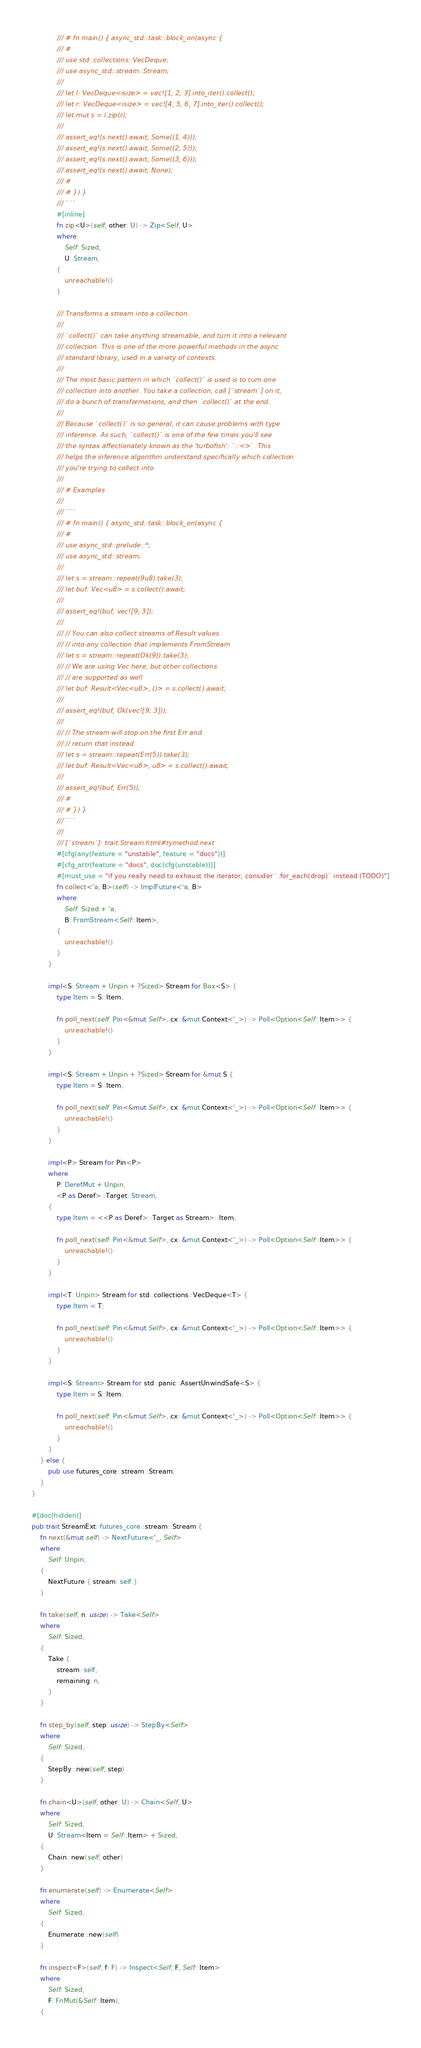<code> <loc_0><loc_0><loc_500><loc_500><_Rust_>            /// # fn main() { async_std::task::block_on(async {
            /// #
            /// use std::collections::VecDeque;
            /// use async_std::stream::Stream;
            ///
            /// let l: VecDeque<isize> = vec![1, 2, 3].into_iter().collect();
            /// let r: VecDeque<isize> = vec![4, 5, 6, 7].into_iter().collect();
            /// let mut s = l.zip(r);
            ///
            /// assert_eq!(s.next().await, Some((1, 4)));
            /// assert_eq!(s.next().await, Some((2, 5)));
            /// assert_eq!(s.next().await, Some((3, 6)));
            /// assert_eq!(s.next().await, None);
            /// #
            /// # }) }
            /// ```
            #[inline]
            fn zip<U>(self, other: U) -> Zip<Self, U>
            where
                Self: Sized,
                U: Stream,
            {
                unreachable!()
            }

            /// Transforms a stream into a collection.
            ///
            /// `collect()` can take anything streamable, and turn it into a relevant
            /// collection. This is one of the more powerful methods in the async
            /// standard library, used in a variety of contexts.
            ///
            /// The most basic pattern in which `collect()` is used is to turn one
            /// collection into another. You take a collection, call [`stream`] on it,
            /// do a bunch of transformations, and then `collect()` at the end.
            ///
            /// Because `collect()` is so general, it can cause problems with type
            /// inference. As such, `collect()` is one of the few times you'll see
            /// the syntax affectionately known as the 'turbofish': `::<>`. This
            /// helps the inference algorithm understand specifically which collection
            /// you're trying to collect into.
            ///
            /// # Examples
            ///
            /// ```
            /// # fn main() { async_std::task::block_on(async {
            /// #
            /// use async_std::prelude::*;
            /// use async_std::stream;
            ///
            /// let s = stream::repeat(9u8).take(3);
            /// let buf: Vec<u8> = s.collect().await;
            ///
            /// assert_eq!(buf, vec![9; 3]);
            ///
            /// // You can also collect streams of Result values
            /// // into any collection that implements FromStream
            /// let s = stream::repeat(Ok(9)).take(3);
            /// // We are using Vec here, but other collections
            /// // are supported as well
            /// let buf: Result<Vec<u8>, ()> = s.collect().await;
            ///
            /// assert_eq!(buf, Ok(vec![9; 3]));
            ///
            /// // The stream will stop on the first Err and
            /// // return that instead
            /// let s = stream::repeat(Err(5)).take(3);
            /// let buf: Result<Vec<u8>, u8> = s.collect().await;
            ///
            /// assert_eq!(buf, Err(5));
            /// #
            /// # }) }
            /// ```
            ///
            /// [`stream`]: trait.Stream.html#tymethod.next
            #[cfg(any(feature = "unstable", feature = "docs"))]
            #[cfg_attr(feature = "docs", doc(cfg(unstable)))]
            #[must_use = "if you really need to exhaust the iterator, consider `.for_each(drop)` instead (TODO)"]
            fn collect<'a, B>(self) -> ImplFuture<'a, B>
            where
                Self: Sized + 'a,
                B: FromStream<Self::Item>,
            {
                unreachable!()
            }
        }

        impl<S: Stream + Unpin + ?Sized> Stream for Box<S> {
            type Item = S::Item;

            fn poll_next(self: Pin<&mut Self>, cx: &mut Context<'_>) -> Poll<Option<Self::Item>> {
                unreachable!()
            }
        }

        impl<S: Stream + Unpin + ?Sized> Stream for &mut S {
            type Item = S::Item;

            fn poll_next(self: Pin<&mut Self>, cx: &mut Context<'_>) -> Poll<Option<Self::Item>> {
                unreachable!()
            }
        }

        impl<P> Stream for Pin<P>
        where
            P: DerefMut + Unpin,
            <P as Deref>::Target: Stream,
        {
            type Item = <<P as Deref>::Target as Stream>::Item;

            fn poll_next(self: Pin<&mut Self>, cx: &mut Context<'_>) -> Poll<Option<Self::Item>> {
                unreachable!()
            }
        }

        impl<T: Unpin> Stream for std::collections::VecDeque<T> {
            type Item = T;

            fn poll_next(self: Pin<&mut Self>, cx: &mut Context<'_>) -> Poll<Option<Self::Item>> {
                unreachable!()
            }
        }

        impl<S: Stream> Stream for std::panic::AssertUnwindSafe<S> {
            type Item = S::Item;

            fn poll_next(self: Pin<&mut Self>, cx: &mut Context<'_>) -> Poll<Option<Self::Item>> {
                unreachable!()
            }
        }
    } else {
        pub use futures_core::stream::Stream;
    }
}

#[doc(hidden)]
pub trait StreamExt: futures_core::stream::Stream {
    fn next(&mut self) -> NextFuture<'_, Self>
    where
        Self: Unpin,
    {
        NextFuture { stream: self }
    }

    fn take(self, n: usize) -> Take<Self>
    where
        Self: Sized,
    {
        Take {
            stream: self,
            remaining: n,
        }
    }

    fn step_by(self, step: usize) -> StepBy<Self>
    where
        Self: Sized,
    {
        StepBy::new(self, step)
    }

    fn chain<U>(self, other: U) -> Chain<Self, U>
    where
        Self: Sized,
        U: Stream<Item = Self::Item> + Sized,
    {
        Chain::new(self, other)
    }

    fn enumerate(self) -> Enumerate<Self>
    where
        Self: Sized,
    {
        Enumerate::new(self)
    }

    fn inspect<F>(self, f: F) -> Inspect<Self, F, Self::Item>
    where
        Self: Sized,
        F: FnMut(&Self::Item),
    {</code> 